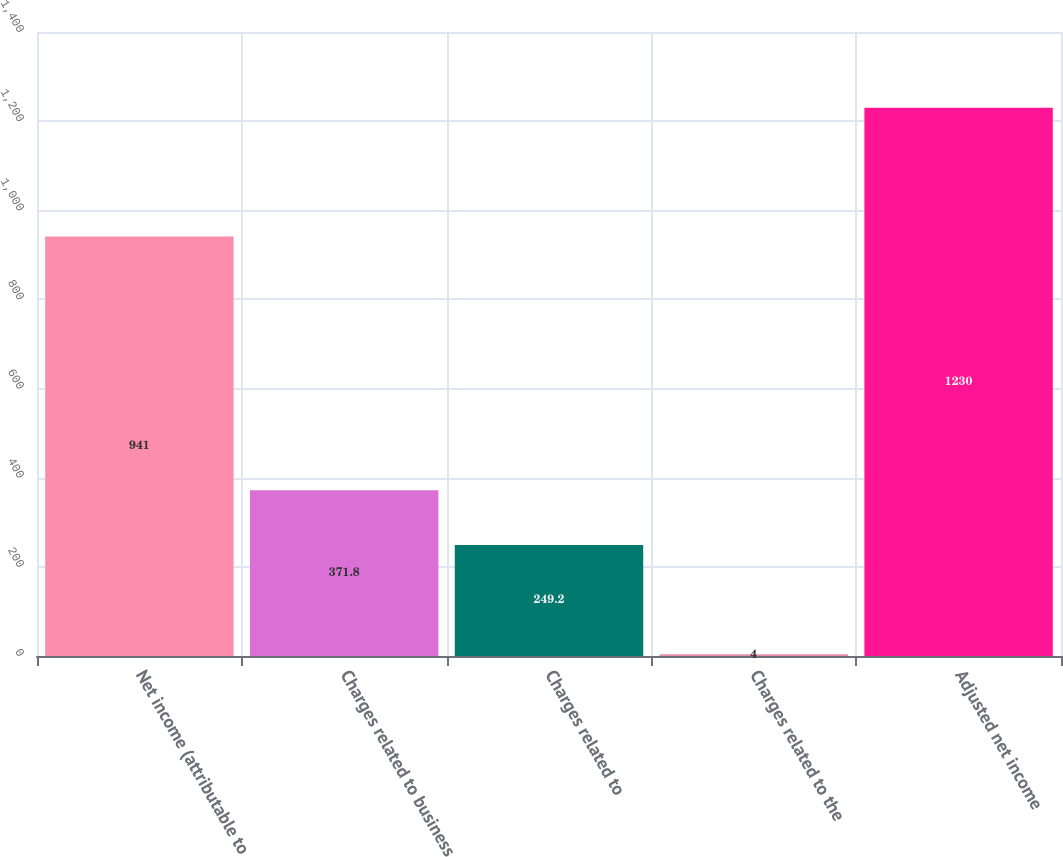<chart> <loc_0><loc_0><loc_500><loc_500><bar_chart><fcel>Net income (attributable to<fcel>Charges related to business<fcel>Charges related to<fcel>Charges related to the<fcel>Adjusted net income<nl><fcel>941<fcel>371.8<fcel>249.2<fcel>4<fcel>1230<nl></chart> 